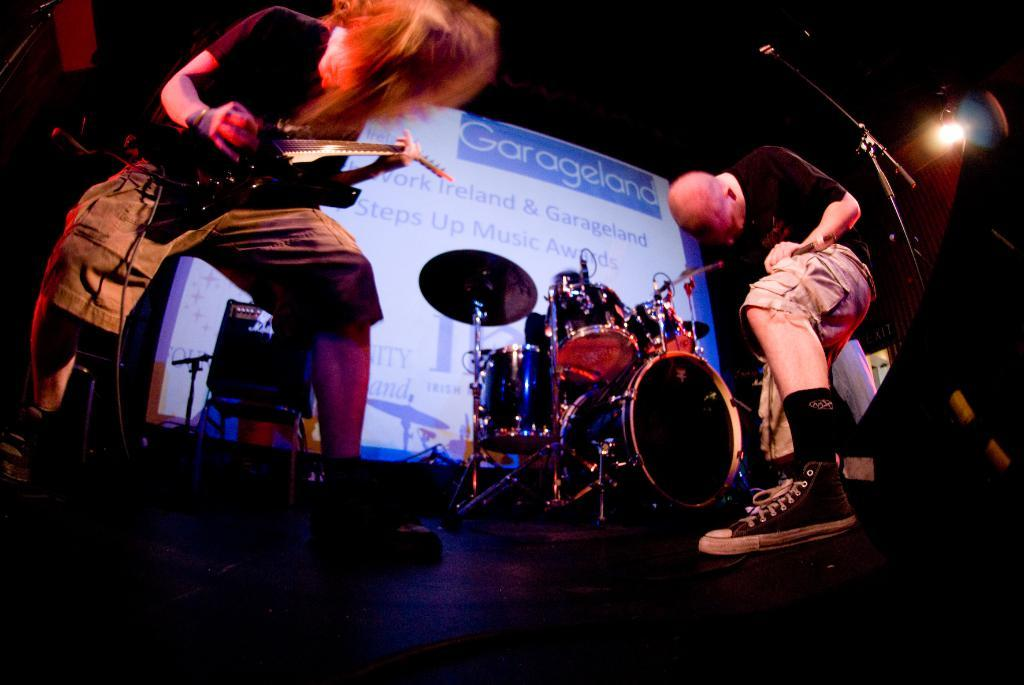What are the people in the image doing? The people in the image are playing musical instruments. Can you describe anything in the background of the image? Yes, there is a banner visible in the background of the image. How many parcels are being delivered to the women in the image? There are no women or parcels present in the image; it features people playing musical instruments. 